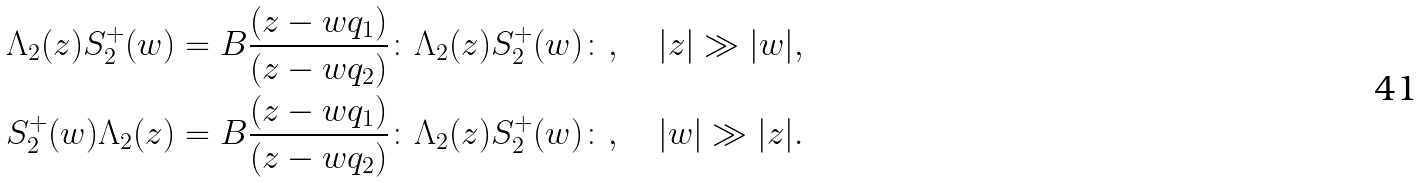Convert formula to latex. <formula><loc_0><loc_0><loc_500><loc_500>\Lambda _ { 2 } ( z ) S ^ { + } _ { 2 } ( w ) = B \frac { ( z - w q _ { 1 } ) } { ( z - w q _ { 2 } ) } \colon \Lambda _ { 2 } ( z ) S ^ { + } _ { 2 } ( w ) \colon , \quad | z | \gg | w | , \\ S ^ { + } _ { 2 } ( w ) \Lambda _ { 2 } ( z ) = B \frac { ( z - w q _ { 1 } ) } { ( z - w q _ { 2 } ) } \colon \Lambda _ { 2 } ( z ) S ^ { + } _ { 2 } ( w ) \colon , \quad | w | \gg | z | .</formula> 